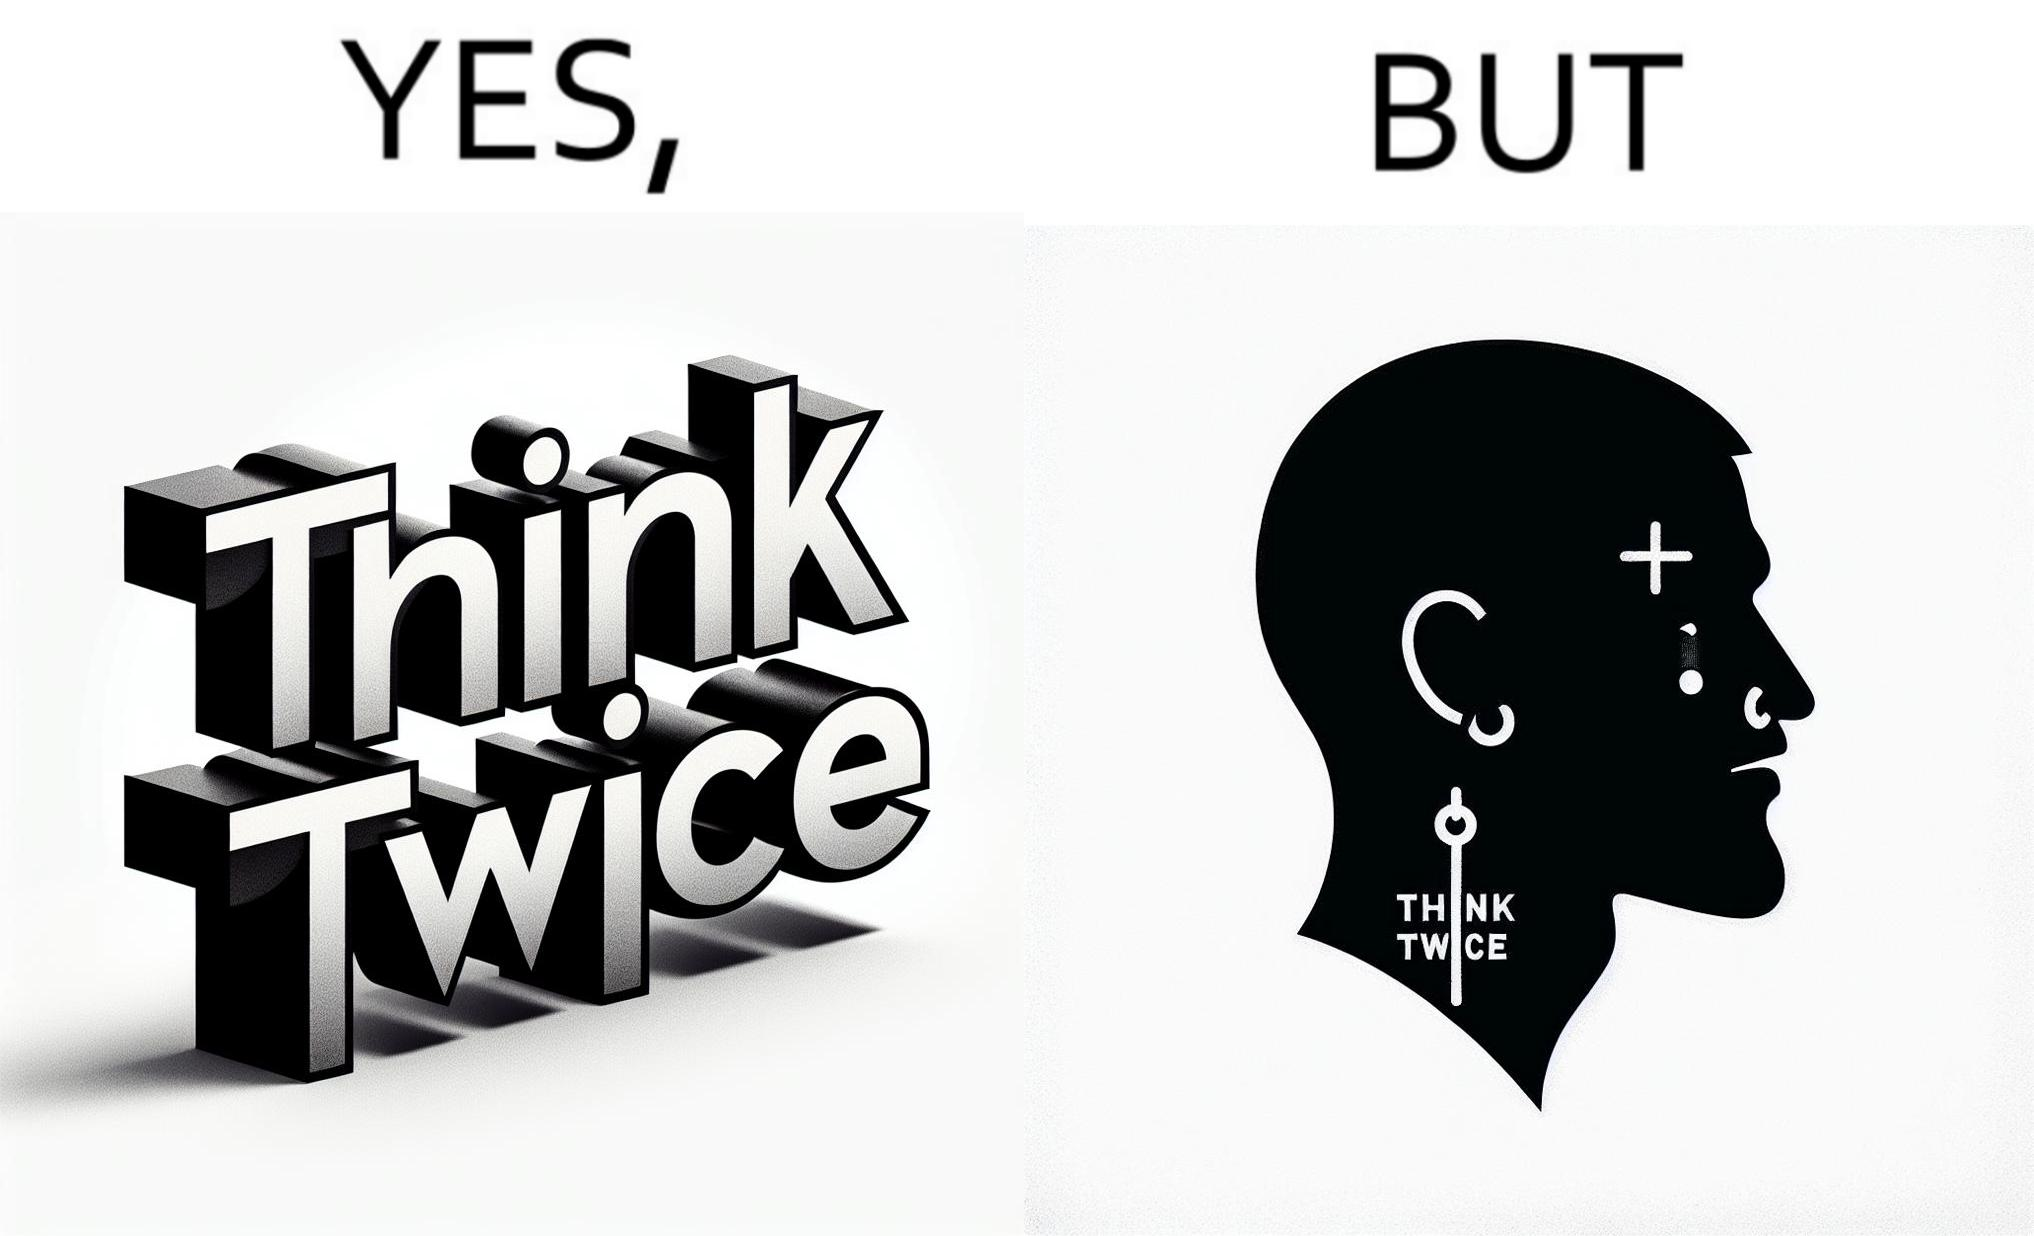What is shown in this image? The image is funny because even thought the tattoo on the face of the man says "think twice", the man did not think twice before getting the tattoo on his forehead. 